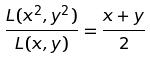<formula> <loc_0><loc_0><loc_500><loc_500>\frac { L ( x ^ { 2 } , y ^ { 2 } ) } { L ( x , y ) } = \frac { x + y } { 2 }</formula> 